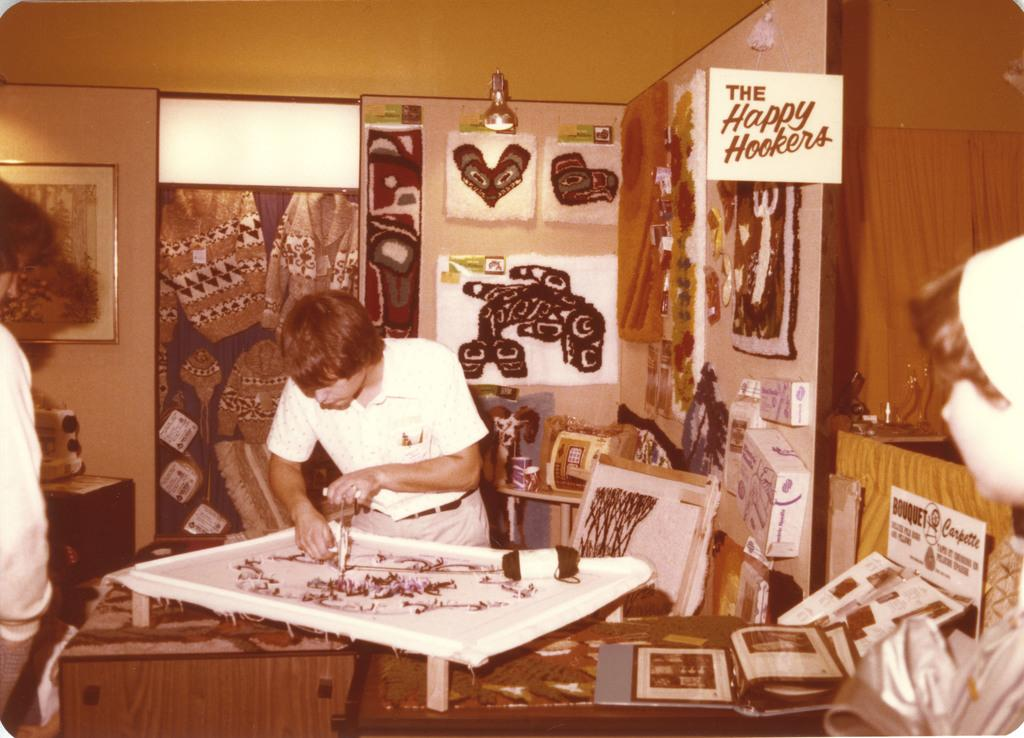What type of structure can be seen in the image? There is a wall in the image. What is hanging on the wall? There is a photo frame and posters hanging on the wall. What type of lighting is present in the image? There are lights in the image. What type of window treatment is present in the image? There is a curtain in the image. How many people are in the image? There are two people in the image. What type of furniture is present in the image? There is a chair and a table in the image. What is on the table? There are photo frames on the table. What type of cloth is being used by the army in the image? There is no army or cloth present in the image. What is the afterthought of the people in the image? There is no indication of an afterthought in the image; it simply shows two people and their surroundings. 